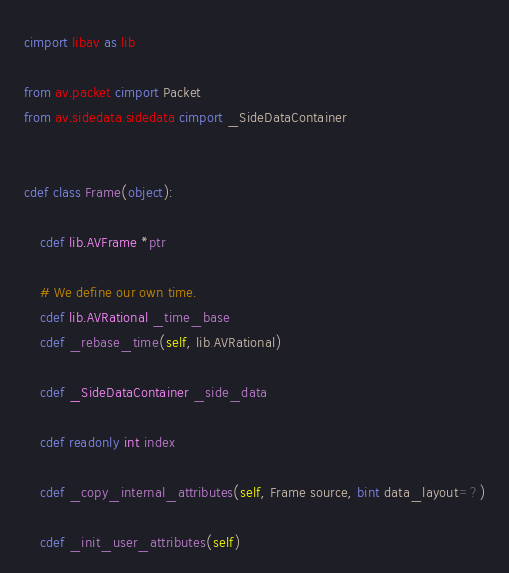<code> <loc_0><loc_0><loc_500><loc_500><_Cython_>cimport libav as lib

from av.packet cimport Packet
from av.sidedata.sidedata cimport _SideDataContainer


cdef class Frame(object):

    cdef lib.AVFrame *ptr

    # We define our own time.
    cdef lib.AVRational _time_base
    cdef _rebase_time(self, lib.AVRational)

    cdef _SideDataContainer _side_data

    cdef readonly int index

    cdef _copy_internal_attributes(self, Frame source, bint data_layout=?)

    cdef _init_user_attributes(self)
</code> 